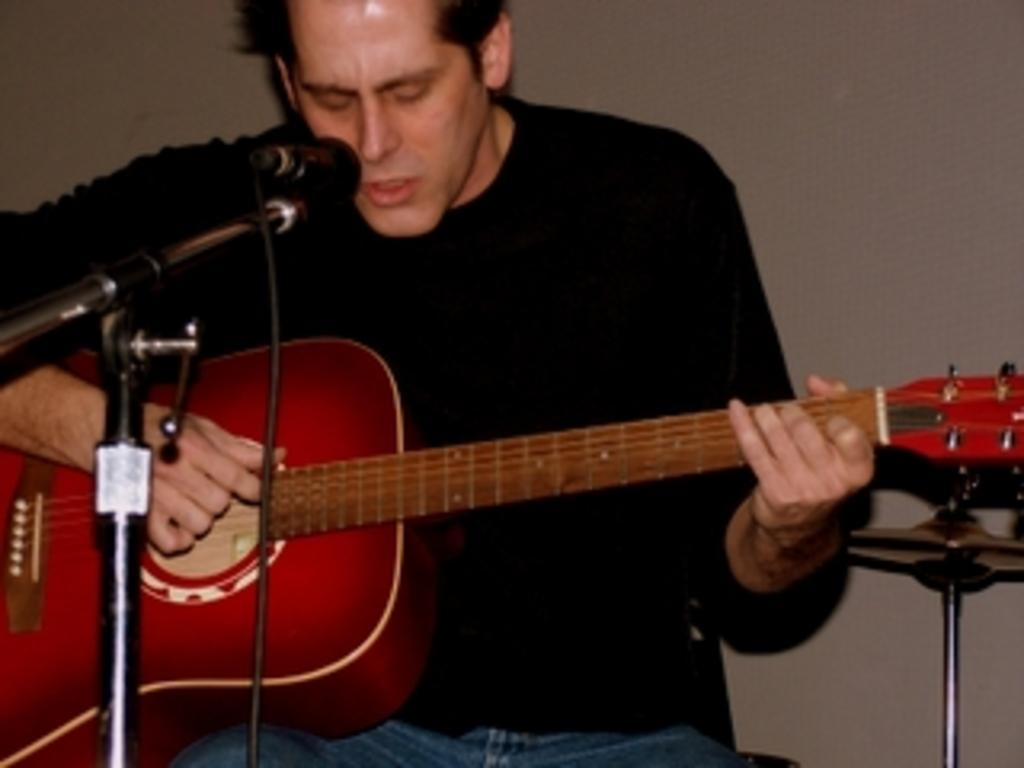Who is the main subject in the image? There is a man in the image. What is the man holding in the image? The man is holding a guitar. What object is in front of the man? There is a microphone in front of the man. What type of turkey is being discovered by the man in the image? There is no turkey present in the image, and the man is not making any discoveries. 